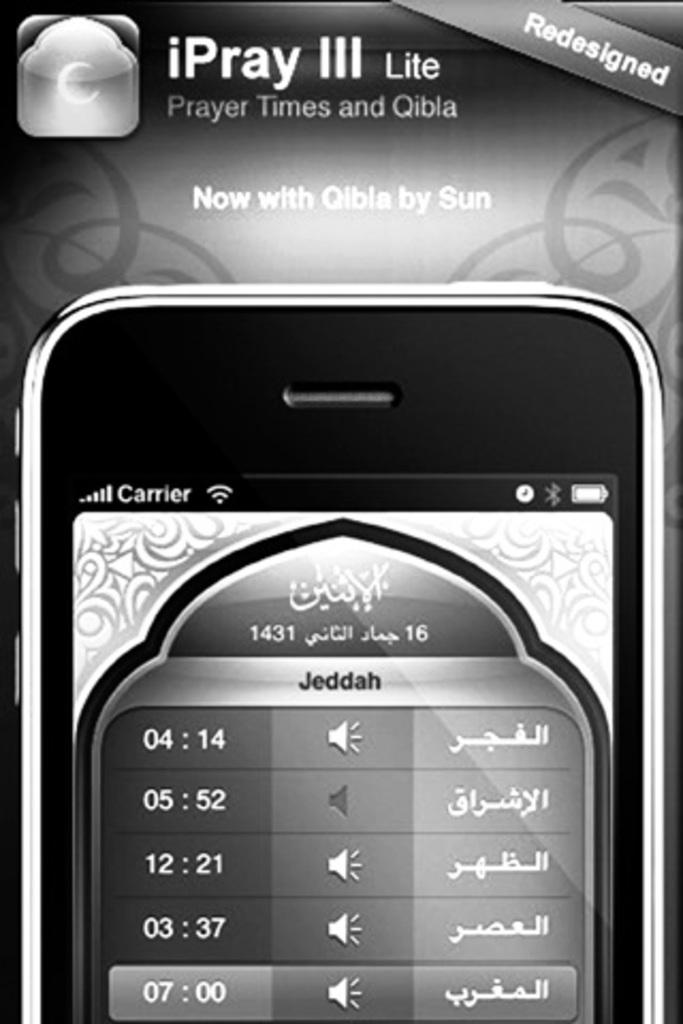<image>
Offer a succinct explanation of the picture presented. a cell phone showing a schedule for praying with IPray III at the top 